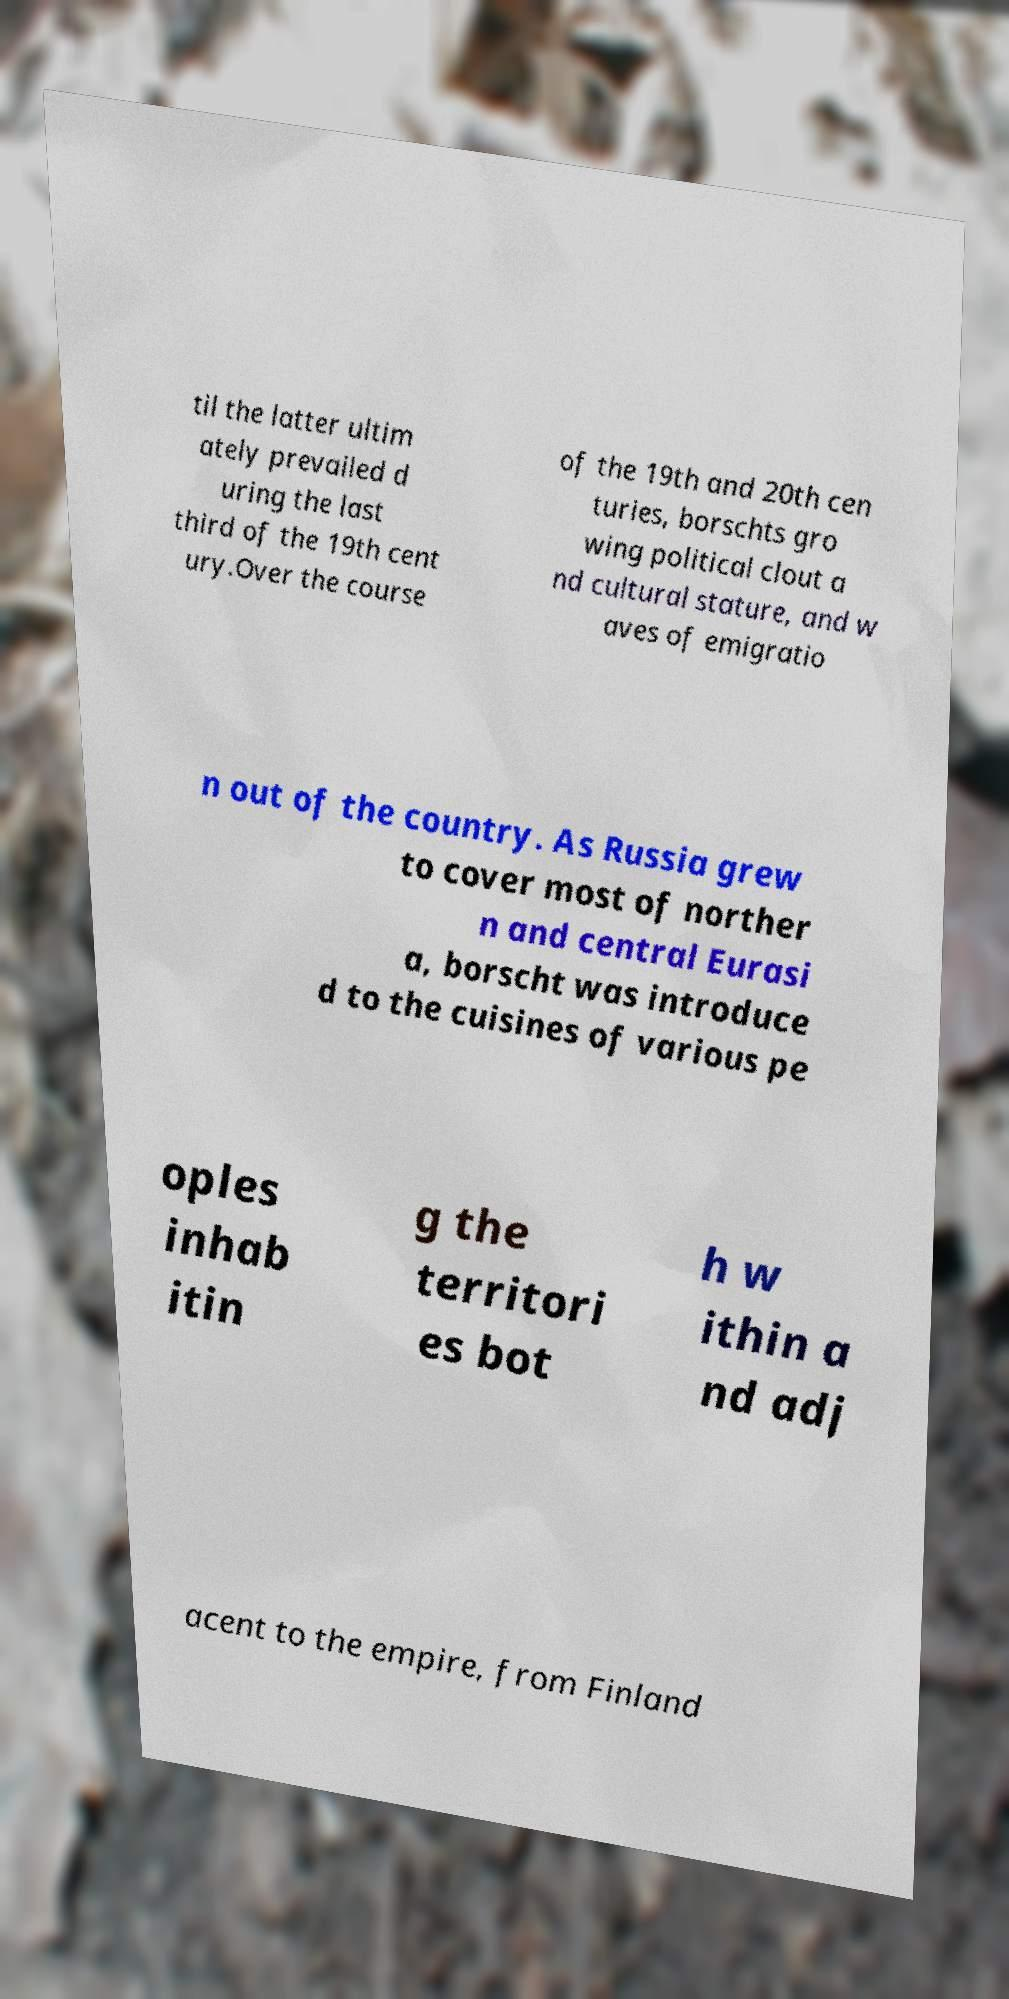There's text embedded in this image that I need extracted. Can you transcribe it verbatim? til the latter ultim ately prevailed d uring the last third of the 19th cent ury.Over the course of the 19th and 20th cen turies, borschts gro wing political clout a nd cultural stature, and w aves of emigratio n out of the country. As Russia grew to cover most of norther n and central Eurasi a, borscht was introduce d to the cuisines of various pe oples inhab itin g the territori es bot h w ithin a nd adj acent to the empire, from Finland 